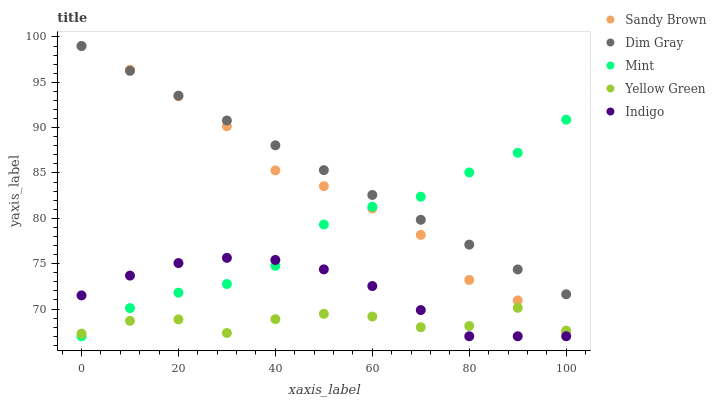Does Yellow Green have the minimum area under the curve?
Answer yes or no. Yes. Does Dim Gray have the maximum area under the curve?
Answer yes or no. Yes. Does Sandy Brown have the minimum area under the curve?
Answer yes or no. No. Does Sandy Brown have the maximum area under the curve?
Answer yes or no. No. Is Dim Gray the smoothest?
Answer yes or no. Yes. Is Yellow Green the roughest?
Answer yes or no. Yes. Is Sandy Brown the smoothest?
Answer yes or no. No. Is Sandy Brown the roughest?
Answer yes or no. No. Does Mint have the lowest value?
Answer yes or no. Yes. Does Sandy Brown have the lowest value?
Answer yes or no. No. Does Sandy Brown have the highest value?
Answer yes or no. Yes. Does Yellow Green have the highest value?
Answer yes or no. No. Is Indigo less than Sandy Brown?
Answer yes or no. Yes. Is Dim Gray greater than Yellow Green?
Answer yes or no. Yes. Does Mint intersect Indigo?
Answer yes or no. Yes. Is Mint less than Indigo?
Answer yes or no. No. Is Mint greater than Indigo?
Answer yes or no. No. Does Indigo intersect Sandy Brown?
Answer yes or no. No. 